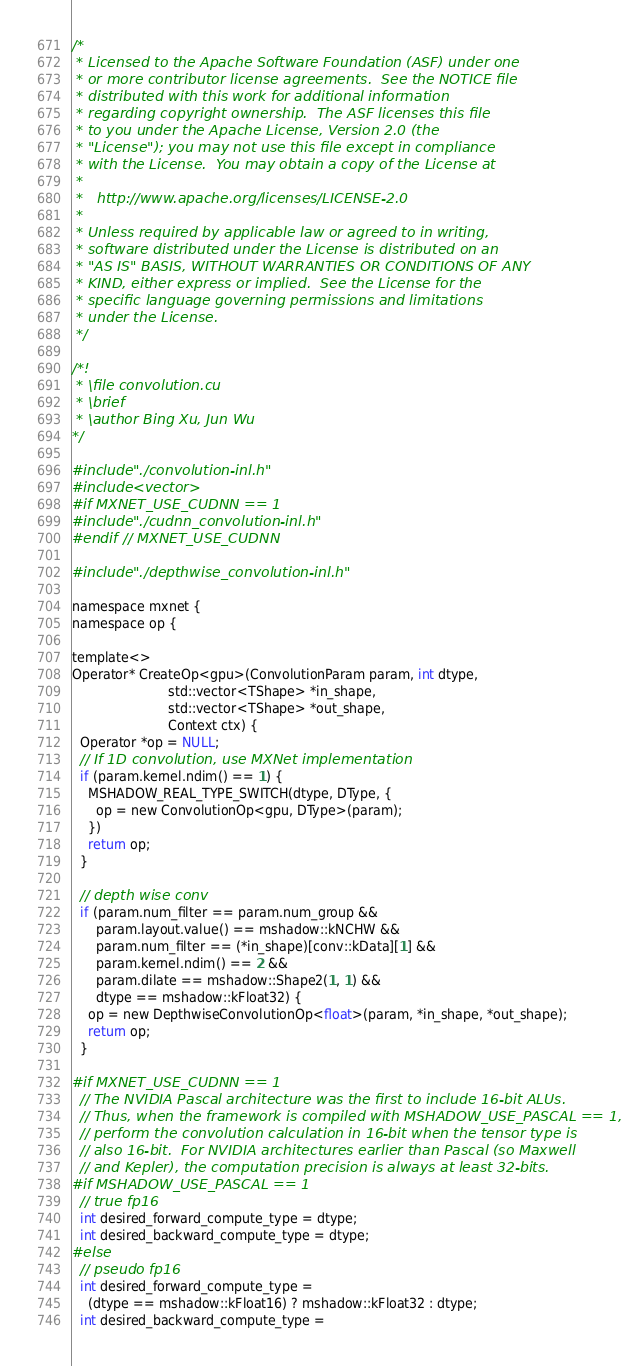<code> <loc_0><loc_0><loc_500><loc_500><_Cuda_>/*
 * Licensed to the Apache Software Foundation (ASF) under one
 * or more contributor license agreements.  See the NOTICE file
 * distributed with this work for additional information
 * regarding copyright ownership.  The ASF licenses this file
 * to you under the Apache License, Version 2.0 (the
 * "License"); you may not use this file except in compliance
 * with the License.  You may obtain a copy of the License at
 *
 *   http://www.apache.org/licenses/LICENSE-2.0
 *
 * Unless required by applicable law or agreed to in writing,
 * software distributed under the License is distributed on an
 * "AS IS" BASIS, WITHOUT WARRANTIES OR CONDITIONS OF ANY
 * KIND, either express or implied.  See the License for the
 * specific language governing permissions and limitations
 * under the License.
 */

/*!
 * \file convolution.cu
 * \brief
 * \author Bing Xu, Jun Wu
*/

#include "./convolution-inl.h"
#include <vector>
#if MXNET_USE_CUDNN == 1
#include "./cudnn_convolution-inl.h"
#endif  // MXNET_USE_CUDNN

#include "./depthwise_convolution-inl.h"

namespace mxnet {
namespace op {

template<>
Operator* CreateOp<gpu>(ConvolutionParam param, int dtype,
                        std::vector<TShape> *in_shape,
                        std::vector<TShape> *out_shape,
                        Context ctx) {
  Operator *op = NULL;
  // If 1D convolution, use MXNet implementation
  if (param.kernel.ndim() == 1) {
    MSHADOW_REAL_TYPE_SWITCH(dtype, DType, {
      op = new ConvolutionOp<gpu, DType>(param);
    })
    return op;
  }

  // depth wise conv
  if (param.num_filter == param.num_group &&
      param.layout.value() == mshadow::kNCHW &&
      param.num_filter == (*in_shape)[conv::kData][1] &&
      param.kernel.ndim() == 2 &&
      param.dilate == mshadow::Shape2(1, 1) &&
      dtype == mshadow::kFloat32) {
    op = new DepthwiseConvolutionOp<float>(param, *in_shape, *out_shape);
    return op;
  }

#if MXNET_USE_CUDNN == 1
  // The NVIDIA Pascal architecture was the first to include 16-bit ALUs.
  // Thus, when the framework is compiled with MSHADOW_USE_PASCAL == 1, we
  // perform the convolution calculation in 16-bit when the tensor type is
  // also 16-bit.  For NVIDIA architectures earlier than Pascal (so Maxwell
  // and Kepler), the computation precision is always at least 32-bits.
#if MSHADOW_USE_PASCAL == 1
  // true fp16
  int desired_forward_compute_type = dtype;
  int desired_backward_compute_type = dtype;
#else
  // pseudo fp16
  int desired_forward_compute_type =
    (dtype == mshadow::kFloat16) ? mshadow::kFloat32 : dtype;
  int desired_backward_compute_type =</code> 